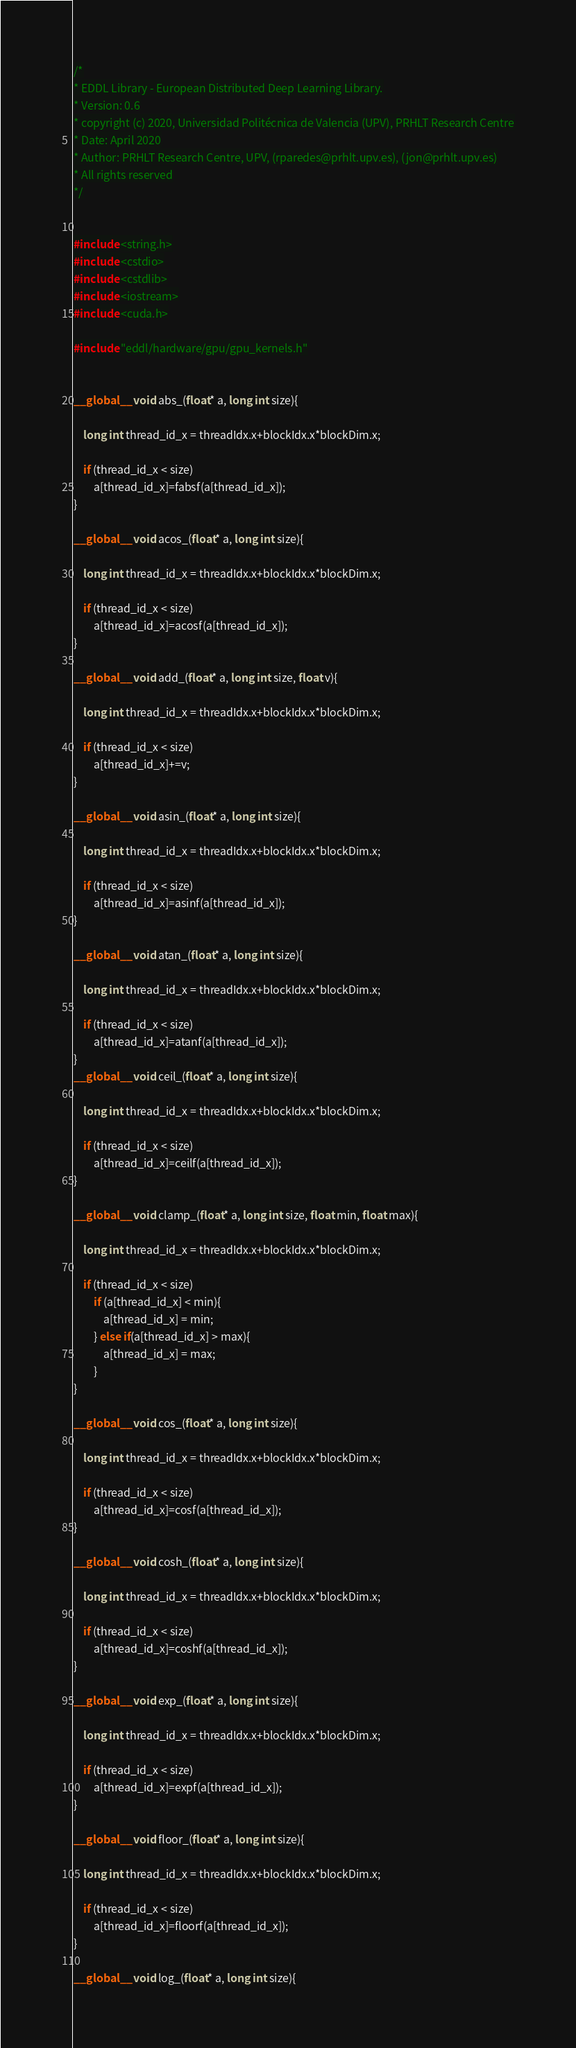Convert code to text. <code><loc_0><loc_0><loc_500><loc_500><_Cuda_>/*
* EDDL Library - European Distributed Deep Learning Library.
* Version: 0.6
* copyright (c) 2020, Universidad Politécnica de Valencia (UPV), PRHLT Research Centre
* Date: April 2020
* Author: PRHLT Research Centre, UPV, (rparedes@prhlt.upv.es), (jon@prhlt.upv.es)
* All rights reserved
*/


#include <string.h>
#include <cstdio>
#include <cstdlib>
#include <iostream>
#include <cuda.h>

#include "eddl/hardware/gpu/gpu_kernels.h"


__global__ void abs_(float* a, long int size){

    long int thread_id_x = threadIdx.x+blockIdx.x*blockDim.x;

    if (thread_id_x < size)
        a[thread_id_x]=fabsf(a[thread_id_x]);
}

__global__ void acos_(float* a, long int size){

    long int thread_id_x = threadIdx.x+blockIdx.x*blockDim.x;

    if (thread_id_x < size)
        a[thread_id_x]=acosf(a[thread_id_x]);
}

__global__ void add_(float* a, long int size, float v){

    long int thread_id_x = threadIdx.x+blockIdx.x*blockDim.x;

    if (thread_id_x < size)
        a[thread_id_x]+=v;
}

__global__ void asin_(float* a, long int size){

    long int thread_id_x = threadIdx.x+blockIdx.x*blockDim.x;

    if (thread_id_x < size)
        a[thread_id_x]=asinf(a[thread_id_x]);
}

__global__ void atan_(float* a, long int size){

    long int thread_id_x = threadIdx.x+blockIdx.x*blockDim.x;

    if (thread_id_x < size)
        a[thread_id_x]=atanf(a[thread_id_x]);
}
__global__ void ceil_(float* a, long int size){

    long int thread_id_x = threadIdx.x+blockIdx.x*blockDim.x;

    if (thread_id_x < size)
        a[thread_id_x]=ceilf(a[thread_id_x]);
}

__global__ void clamp_(float* a, long int size, float min, float max){

    long int thread_id_x = threadIdx.x+blockIdx.x*blockDim.x;

    if (thread_id_x < size)
        if (a[thread_id_x] < min){
            a[thread_id_x] = min;
        } else if(a[thread_id_x] > max){
            a[thread_id_x] = max;
        }
}

__global__ void cos_(float* a, long int size){

    long int thread_id_x = threadIdx.x+blockIdx.x*blockDim.x;

    if (thread_id_x < size)
        a[thread_id_x]=cosf(a[thread_id_x]);
}

__global__ void cosh_(float* a, long int size){

    long int thread_id_x = threadIdx.x+blockIdx.x*blockDim.x;

    if (thread_id_x < size)
        a[thread_id_x]=coshf(a[thread_id_x]);
}

__global__ void exp_(float* a, long int size){

    long int thread_id_x = threadIdx.x+blockIdx.x*blockDim.x;

    if (thread_id_x < size)
        a[thread_id_x]=expf(a[thread_id_x]);
}

__global__ void floor_(float* a, long int size){

    long int thread_id_x = threadIdx.x+blockIdx.x*blockDim.x;

    if (thread_id_x < size)
        a[thread_id_x]=floorf(a[thread_id_x]);
}

__global__ void log_(float* a, long int size){
</code> 